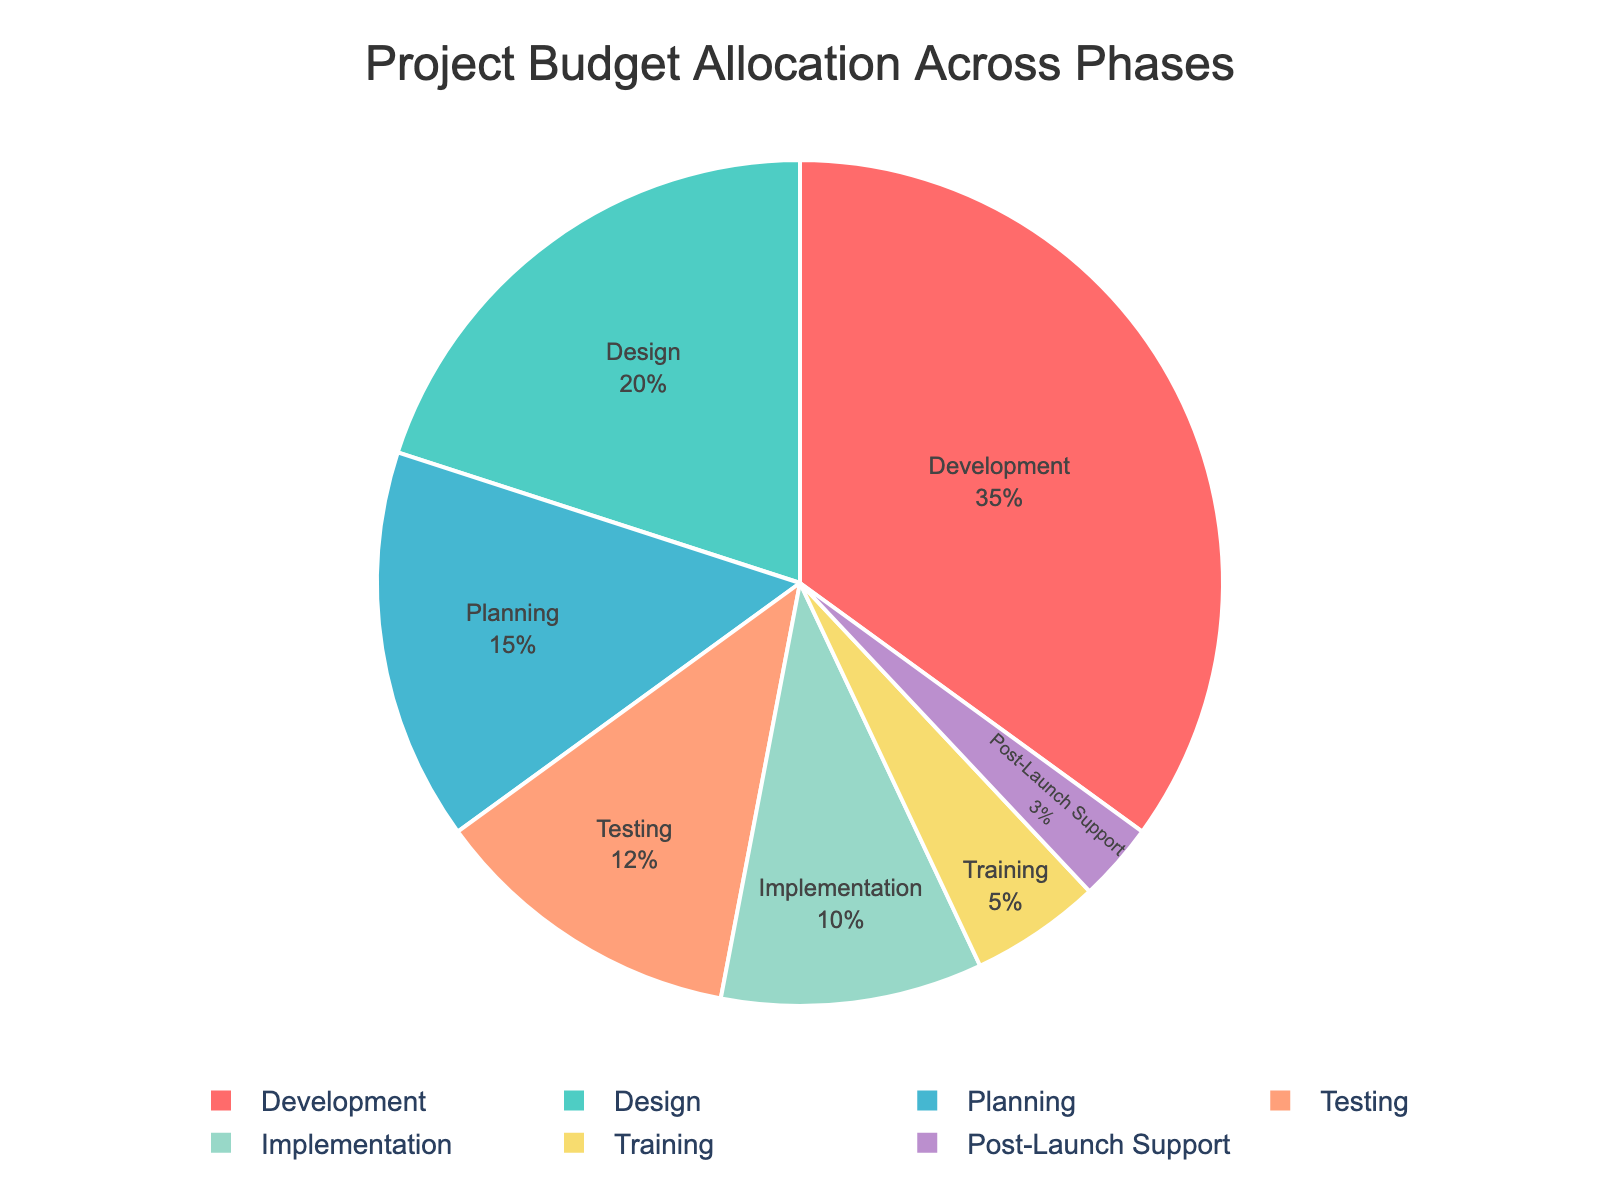What is the total budget allocation for the Planning and Design phases? The Planning phase has a budget allocation of 15, and the Design phase has a budget allocation of 20. Summing these values, 15 + 20, gives the total budget allocation for the two phases.
Answer: 35 Which phase has the highest budget allocation? By examining the pie chart, we see that the Development phase has the largest section, indicating the highest budget allocation.
Answer: Development What percentage of the total budget is allocated to the Training phase? The Training phase is shown to have a 5 budget allocation. By observing the pie chart, the percentage for the Training phase is explicitly shown inside the segment.
Answer: 5% How does the budget allocation for Testing compare to Implementation? The Testing phase has an allocation of 12, while the Implementation phase has an allocation of 10. Comparing these values, 12 is greater than 10.
Answer: Testing has a higher budget Which phase has the smallest budget allocation, and what is its value? The smallest section in the pie chart is for the Post-Launch Support phase, indicating this phase has the smallest budget allocation. The value inside this segment is 3.
Answer: Post-Launch Support with 3 Calculate the combined budget allocation for phases with less than 10? Budget allocations for phases less than 10 are Implementation (10), Training (5), and Post-Launch Support (3). Summing these values, 10 + 5 + 3 = 18.
Answer: 18 What is the color assigned to the Development phase in the pie chart? By visually observing the pie chart, the Development phase segment is displayed in blue.
Answer: Blue Compare the combined budget allocation of Design and Development phases with the Testing phase. Are they greater or less? The Design phase has an allocation of 20 and the Development phase has an allocation of 35. The combined allocation is 20 + 35 = 55. The Testing phase has an allocation of 12. Since 55 is greater than 12, the combined budget allocation for Design and Development is greater than Testing.
Answer: Greater What is the visual difference in the sizes of the pie sections for the Planning phase and the Design phase? The Planning phase segment is visually smaller than the Design phase segment in the pie chart. The Design phase occupies a larger section of the pie chart compared to Planning.
Answer: Design phase segment is larger 